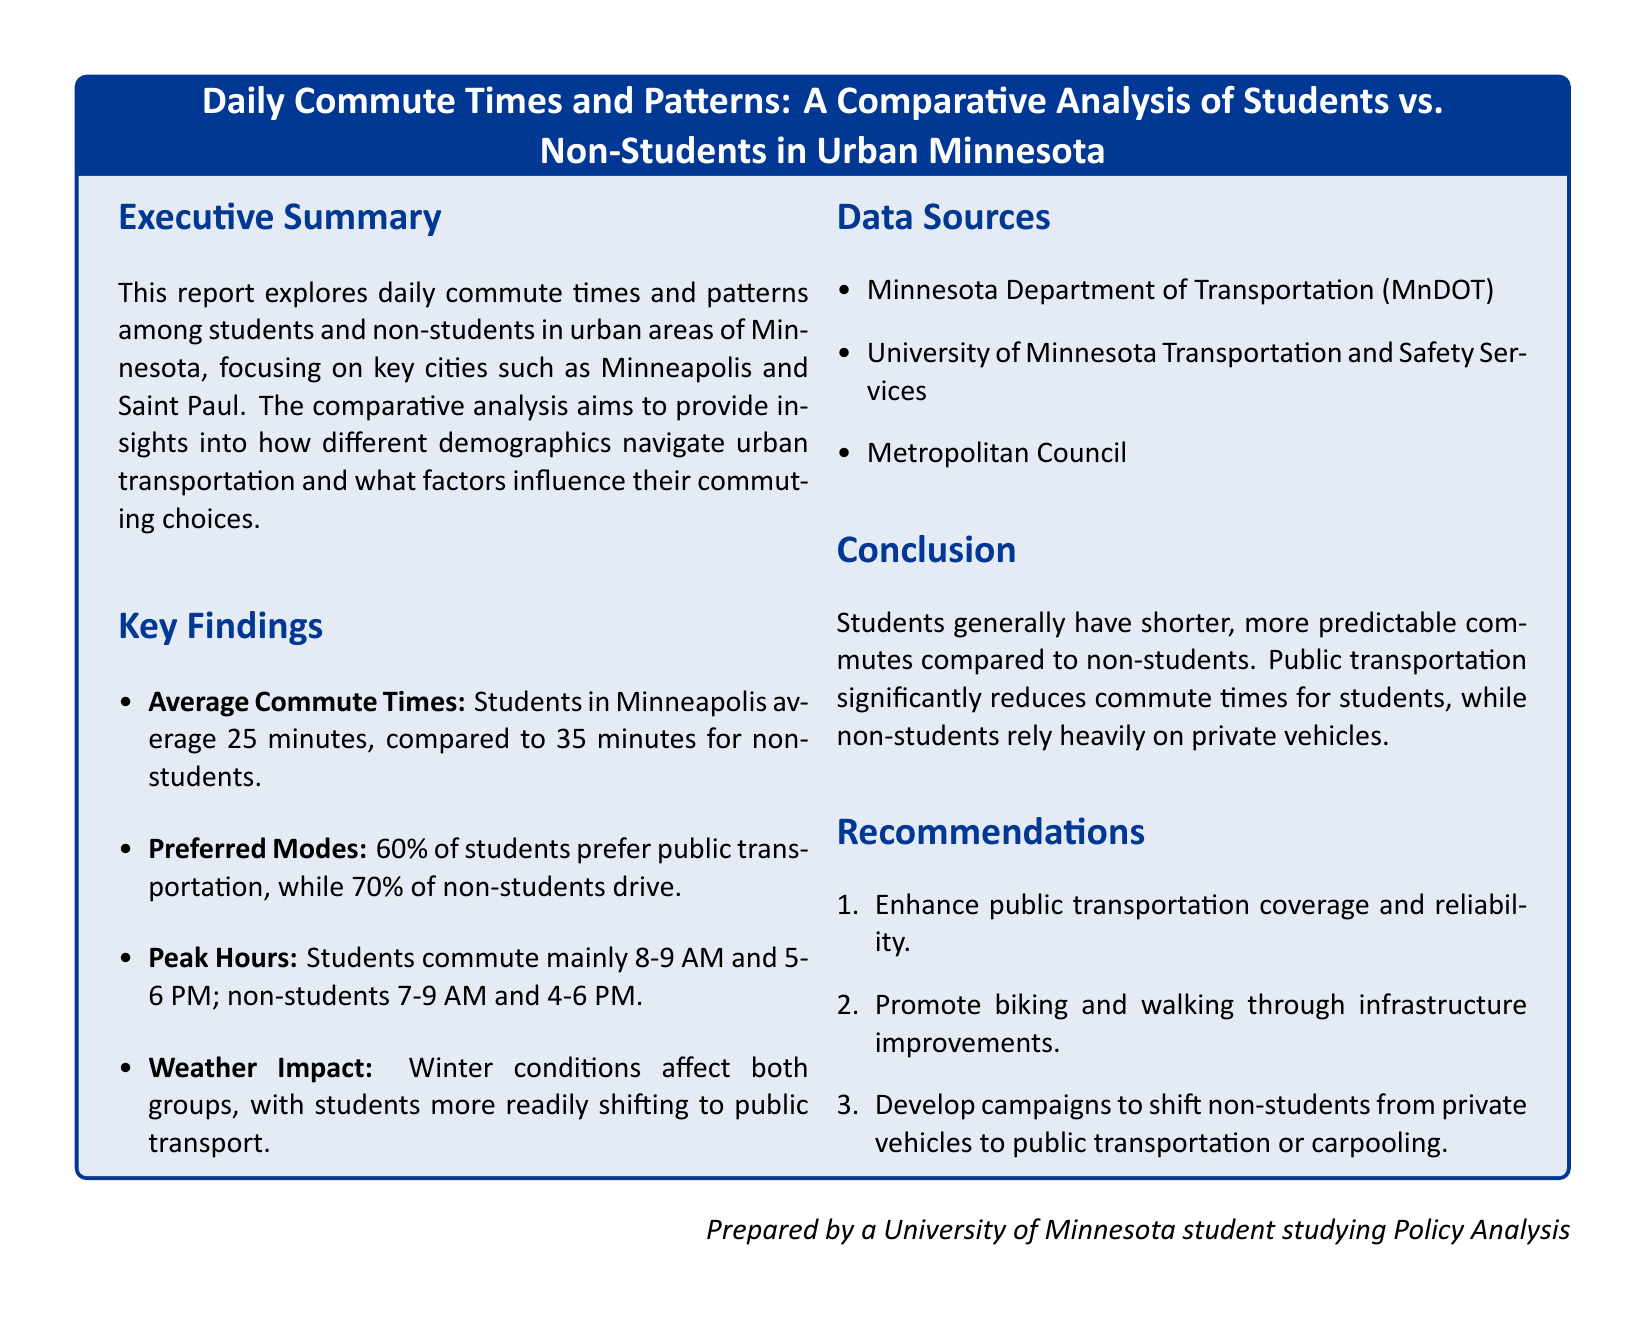what is the average commute time for students? The document states that students in Minneapolis average a commute time of 25 minutes.
Answer: 25 minutes what is the preferred mode of transportation for non-students? The report indicates that 70% of non-students prefer to drive for their commute.
Answer: drive during which hours do students mainly commute? The document mentions that students primarily commute between 8-9 AM and 5-6 PM.
Answer: 8-9 AM and 5-6 PM what is one key finding related to weather impact? The report notes that winter conditions affect both groups, but students shift to public transport more readily.
Answer: students shift to public transport what percentage of students prefer public transportation? According to the document, 60% of students prefer public transportation for their commute.
Answer: 60% what are two recommendations from the report? The report recommends enhancing public transportation coverage and promoting biking and walking through infrastructure improvements.
Answer: enhance public transportation coverage; promote biking and walking what is the main focus of the comparative analysis? The document focuses on how different demographics navigate urban transportation in Minnesota.
Answer: different demographics navigate urban transportation what data sources were used in the analysis? The analysis is based on data from Minnesota Department of Transportation, University of Minnesota Transportation and Safety Services, and Metropolitan Council.
Answer: MnDOT, University of Minnesota, Metropolitan Council 